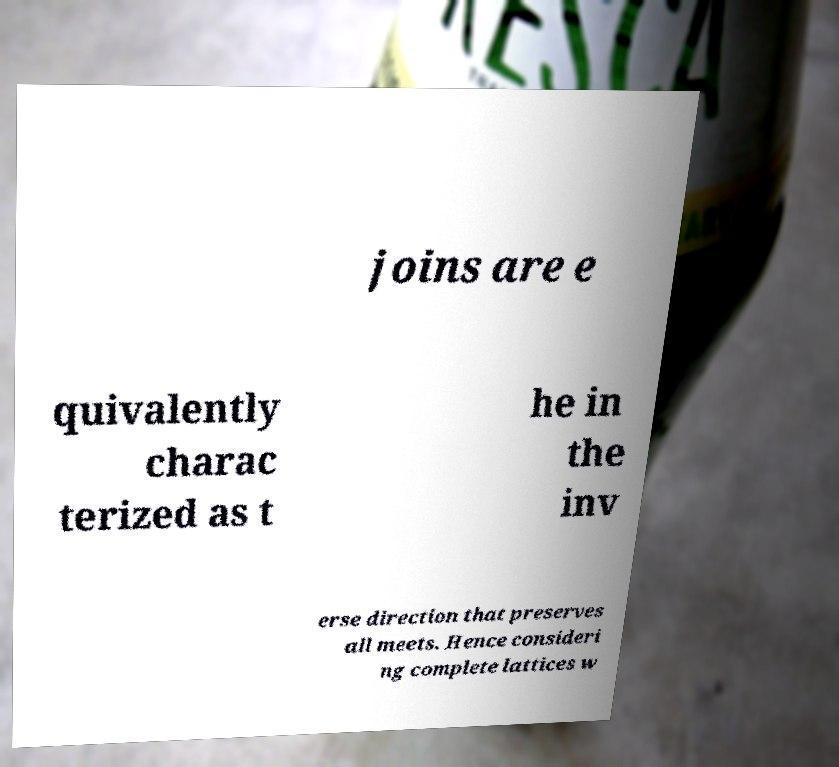What messages or text are displayed in this image? I need them in a readable, typed format. joins are e quivalently charac terized as t he in the inv erse direction that preserves all meets. Hence consideri ng complete lattices w 